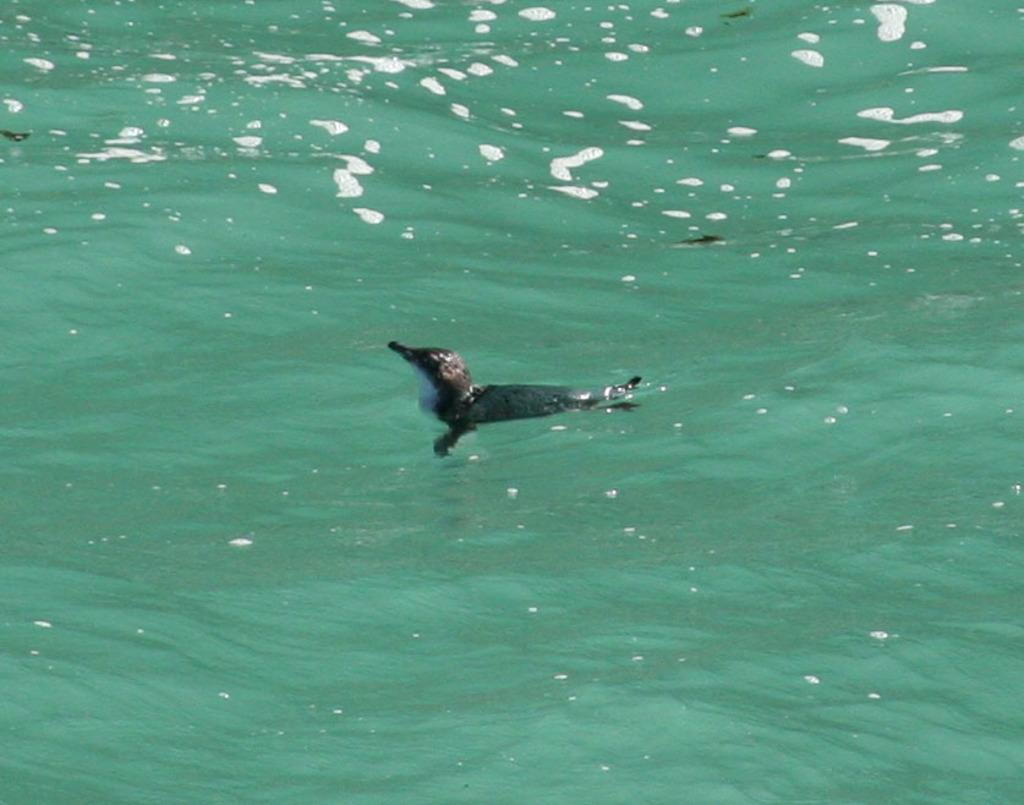What is the primary element visible in the image? There is water in the image. What type of animal can be seen in the image? There is a bird in the image. Where is the bird located in relation to the water? The bird is on the water. What fact can be learned about the bird's control over the water in the image? There is no information about the bird's control over the water in the image. 